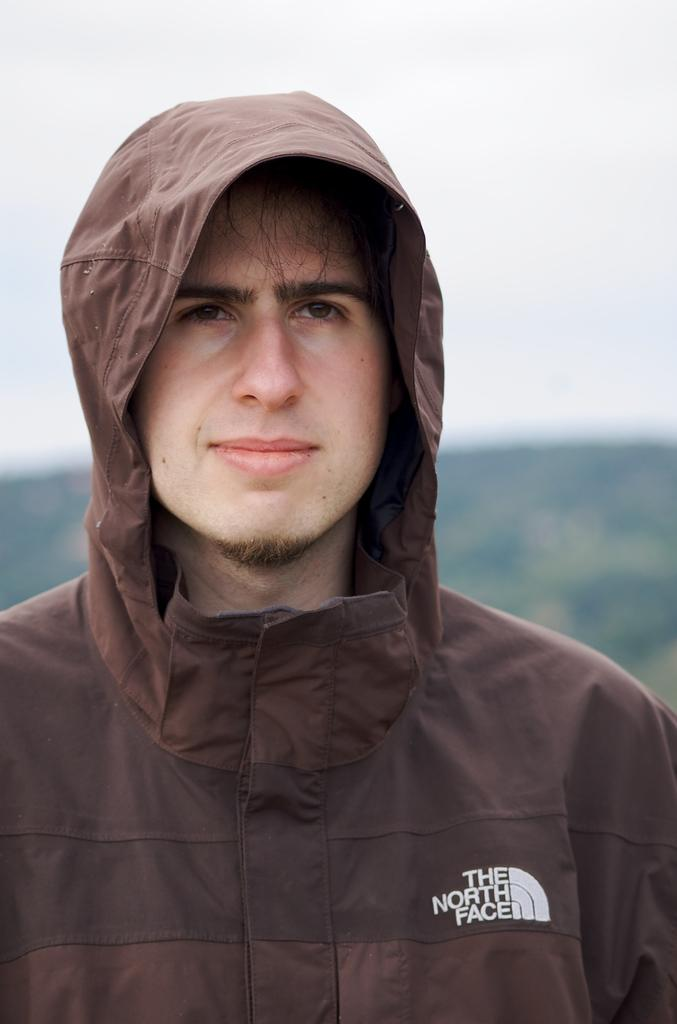What is the main subject in the foreground of the image? There is a person in the foreground of the image. What is the person wearing in the image? The person is wearing a brown color hoodie. What can be seen in the background of the image? The background of the image includes the sky and other objects. What degree does the person in the image have? There is no information about the person's degree in the image. How is the hook used in the image? There is no hook present in the image. 